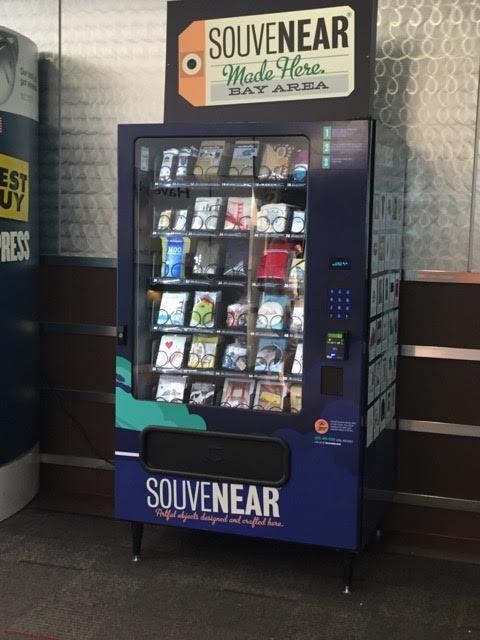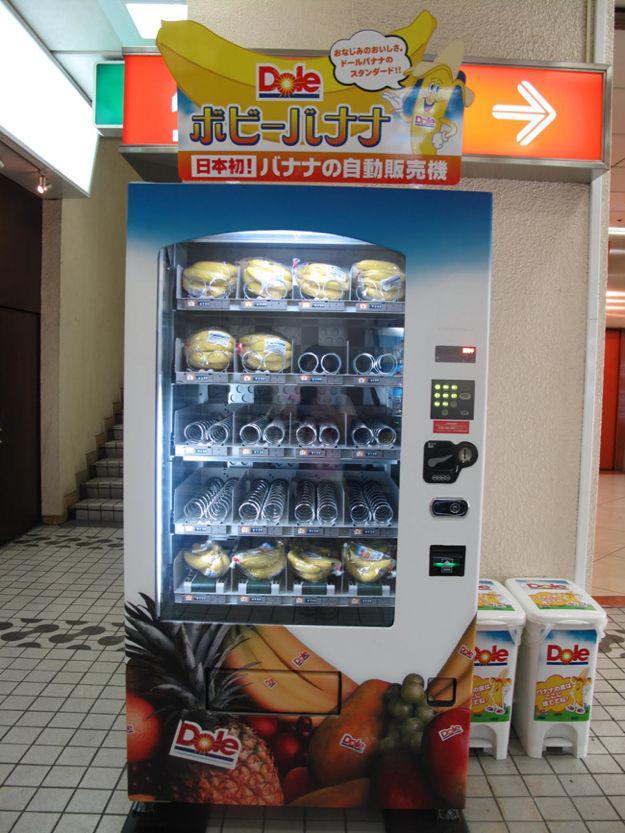The first image is the image on the left, the second image is the image on the right. For the images displayed, is the sentence "At least one of the images in each set contains only one vending machine." factually correct? Answer yes or no. Yes. The first image is the image on the left, the second image is the image on the right. Considering the images on both sides, is "Each image has two or fewer vending machines." valid? Answer yes or no. Yes. 